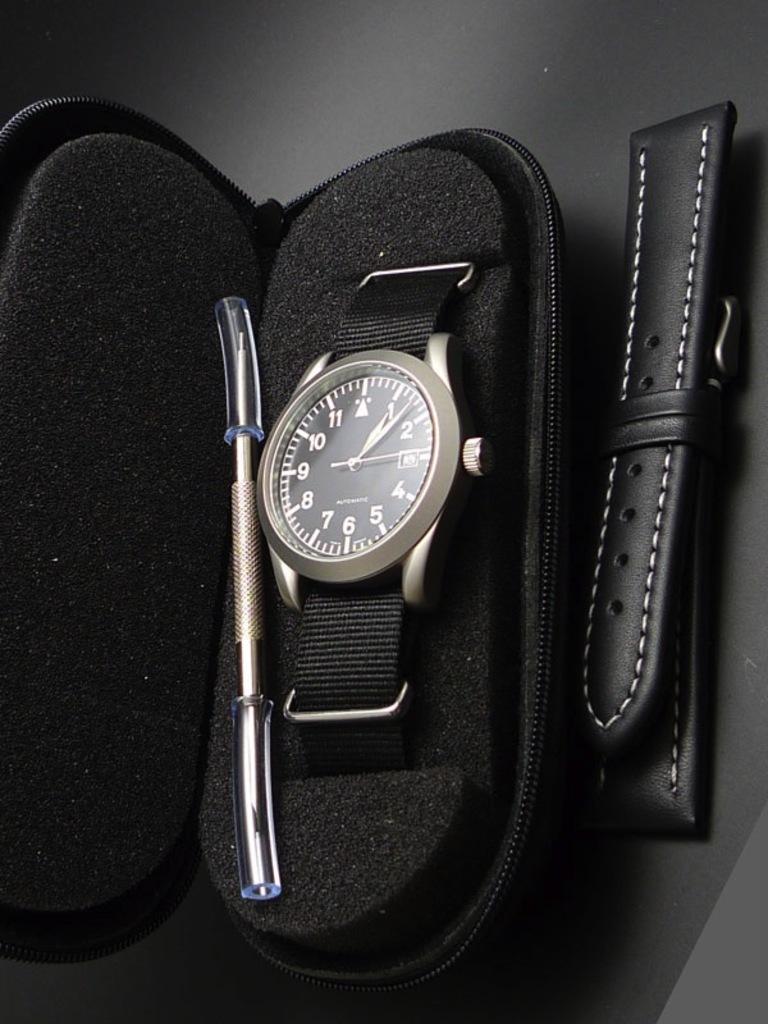What time is currently on the watch?
Make the answer very short. 1:07. 